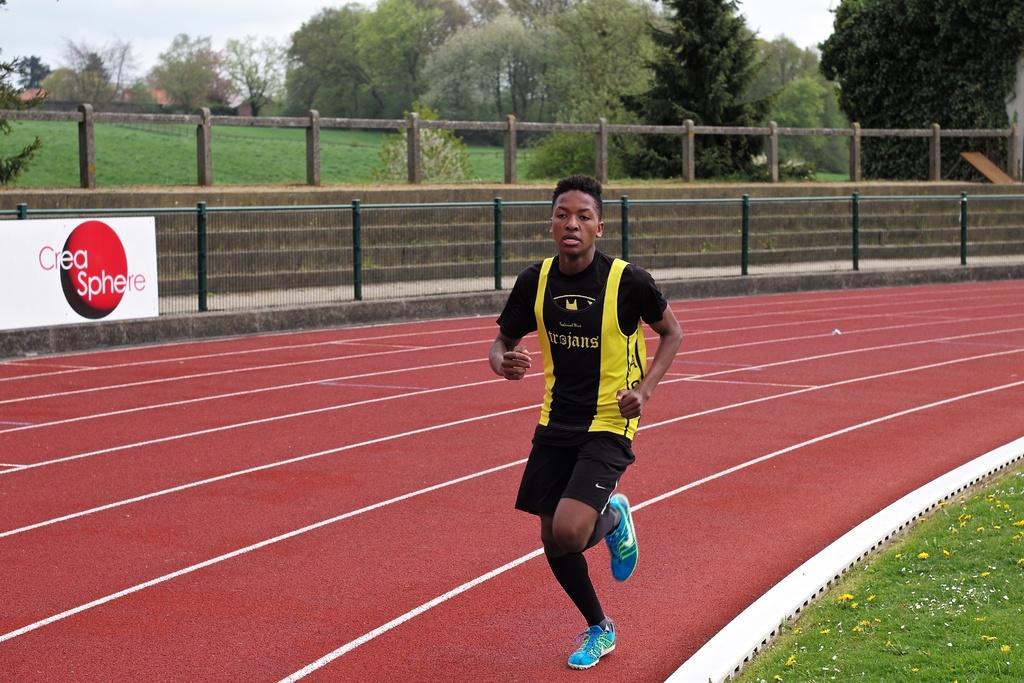Can you describe this image briefly? In this image we can see a man running on the ground. We can also see some grass, flowers, a fence, the staircase, a barricade, a board with some text on it, a group of trees and the sky which looks cloudy. 